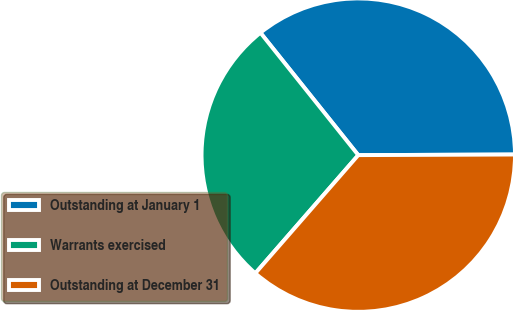<chart> <loc_0><loc_0><loc_500><loc_500><pie_chart><fcel>Outstanding at January 1<fcel>Warrants exercised<fcel>Outstanding at December 31<nl><fcel>35.67%<fcel>27.86%<fcel>36.47%<nl></chart> 